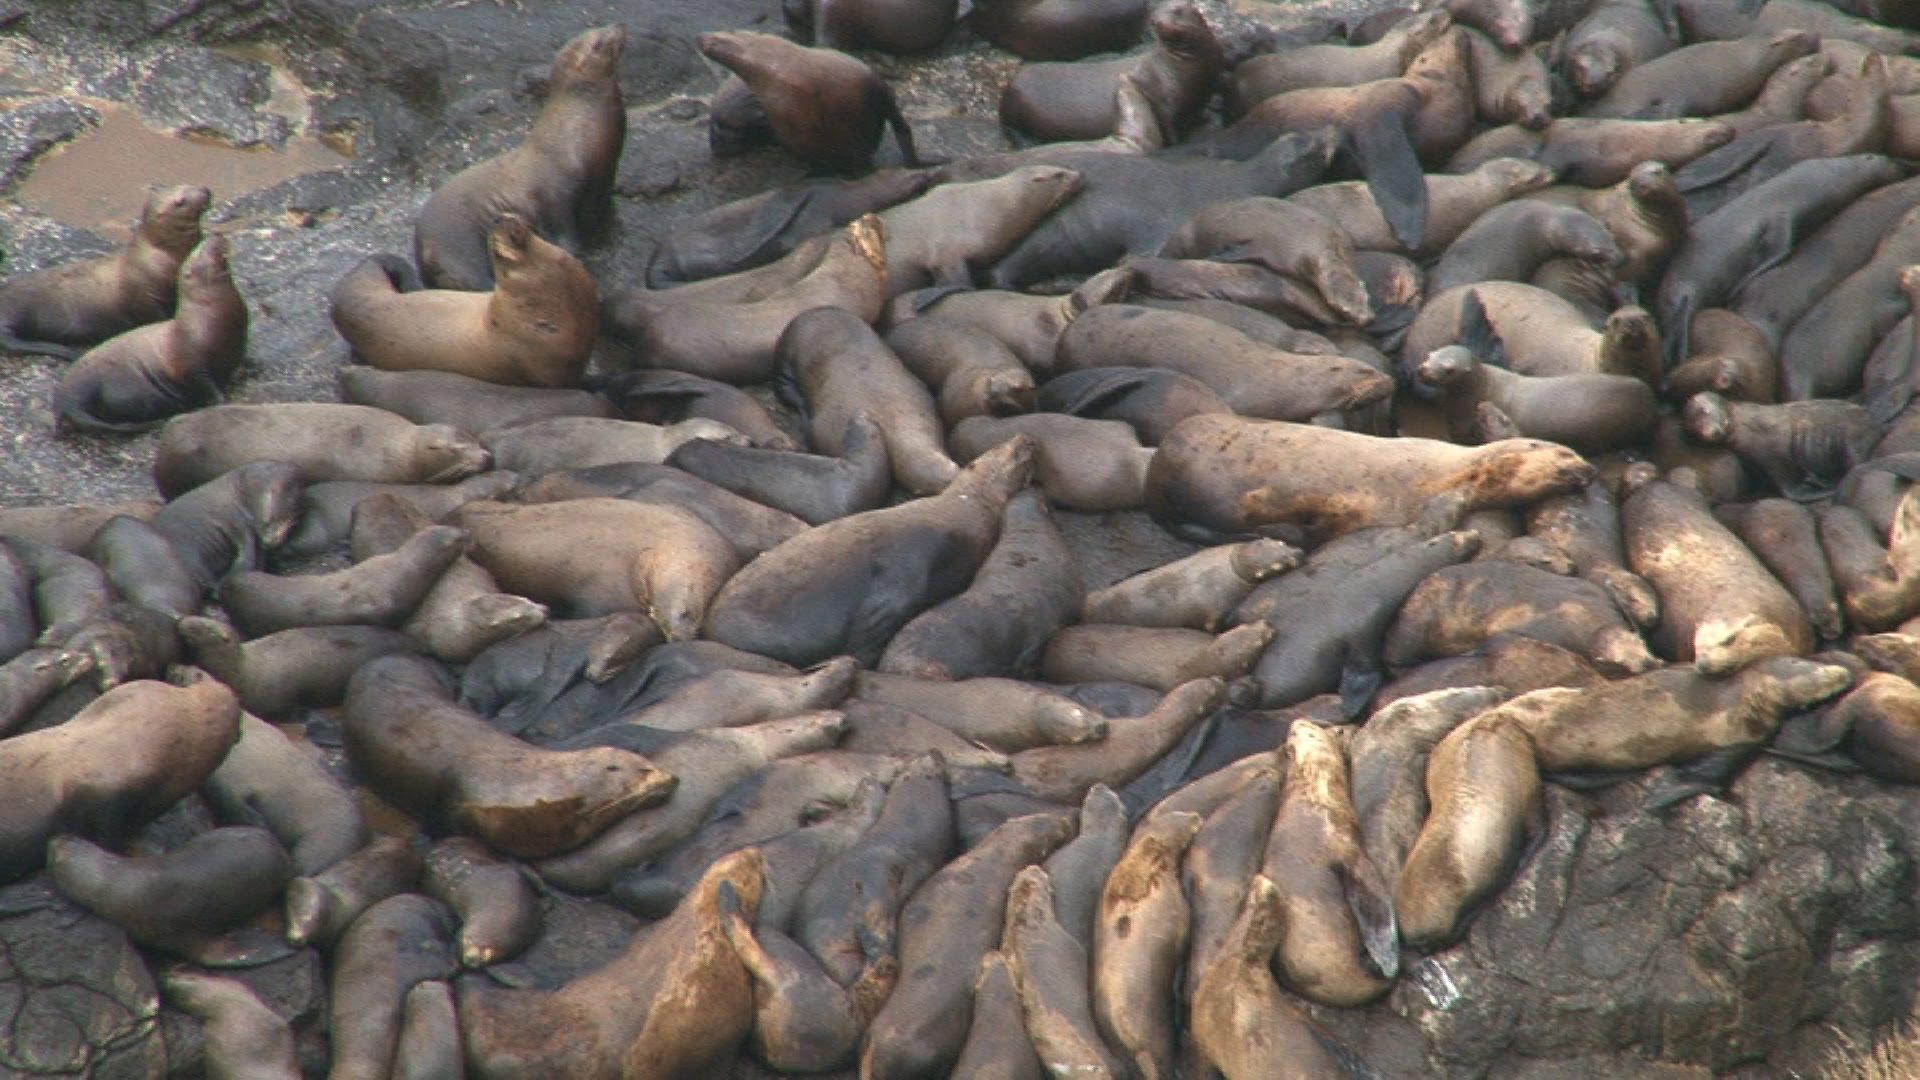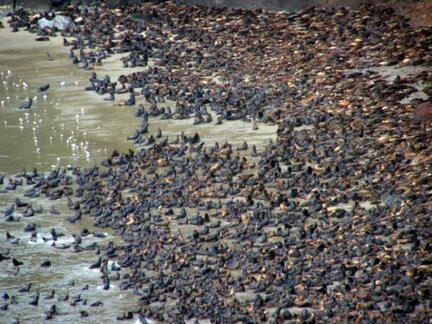The first image is the image on the left, the second image is the image on the right. Assess this claim about the two images: "One or more of the photos shows sealions on a rock inside a cave.". Correct or not? Answer yes or no. No. 